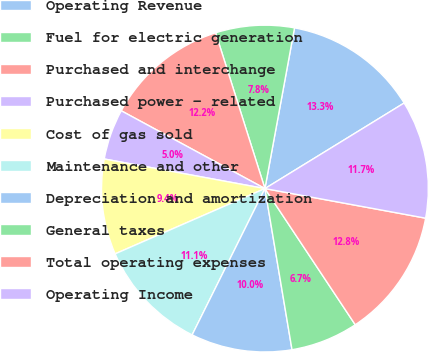Convert chart to OTSL. <chart><loc_0><loc_0><loc_500><loc_500><pie_chart><fcel>Operating Revenue<fcel>Fuel for electric generation<fcel>Purchased and interchange<fcel>Purchased power - related<fcel>Cost of gas sold<fcel>Maintenance and other<fcel>Depreciation and amortization<fcel>General taxes<fcel>Total operating expenses<fcel>Operating Income<nl><fcel>13.33%<fcel>7.78%<fcel>12.22%<fcel>5.0%<fcel>9.44%<fcel>11.11%<fcel>10.0%<fcel>6.67%<fcel>12.78%<fcel>11.67%<nl></chart> 